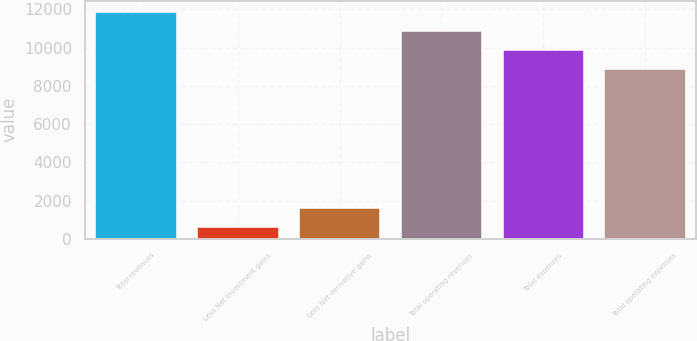Convert chart. <chart><loc_0><loc_0><loc_500><loc_500><bar_chart><fcel>Total revenues<fcel>Less Net investment gains<fcel>Less Net derivative gains<fcel>Total operating revenues<fcel>Total expenses<fcel>Total operating expenses<nl><fcel>11861.6<fcel>616<fcel>1608.2<fcel>10869.4<fcel>9877.2<fcel>8885<nl></chart> 